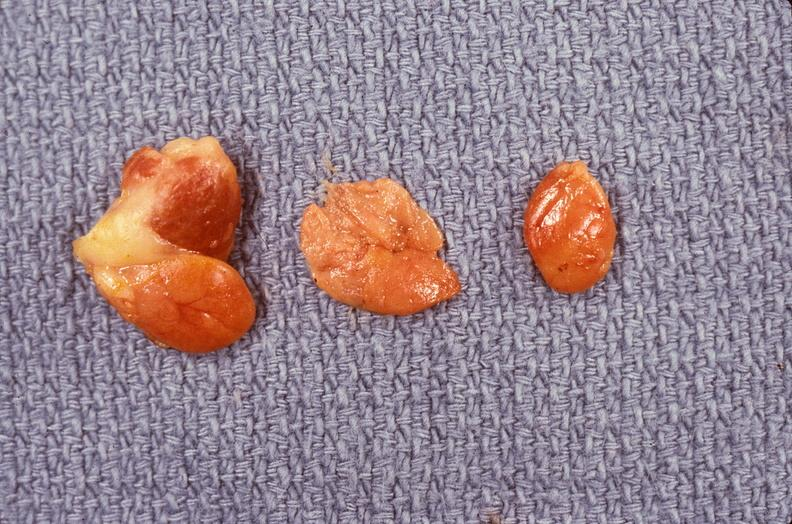what does this image show?
Answer the question using a single word or phrase. Parathyroid hyperplasia 